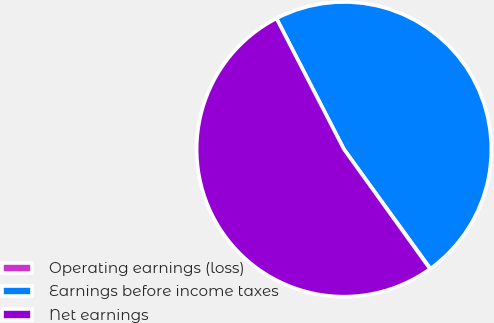Convert chart. <chart><loc_0><loc_0><loc_500><loc_500><pie_chart><fcel>Operating earnings (loss)<fcel>Earnings before income taxes<fcel>Net earnings<nl><fcel>0.06%<fcel>47.59%<fcel>52.34%<nl></chart> 